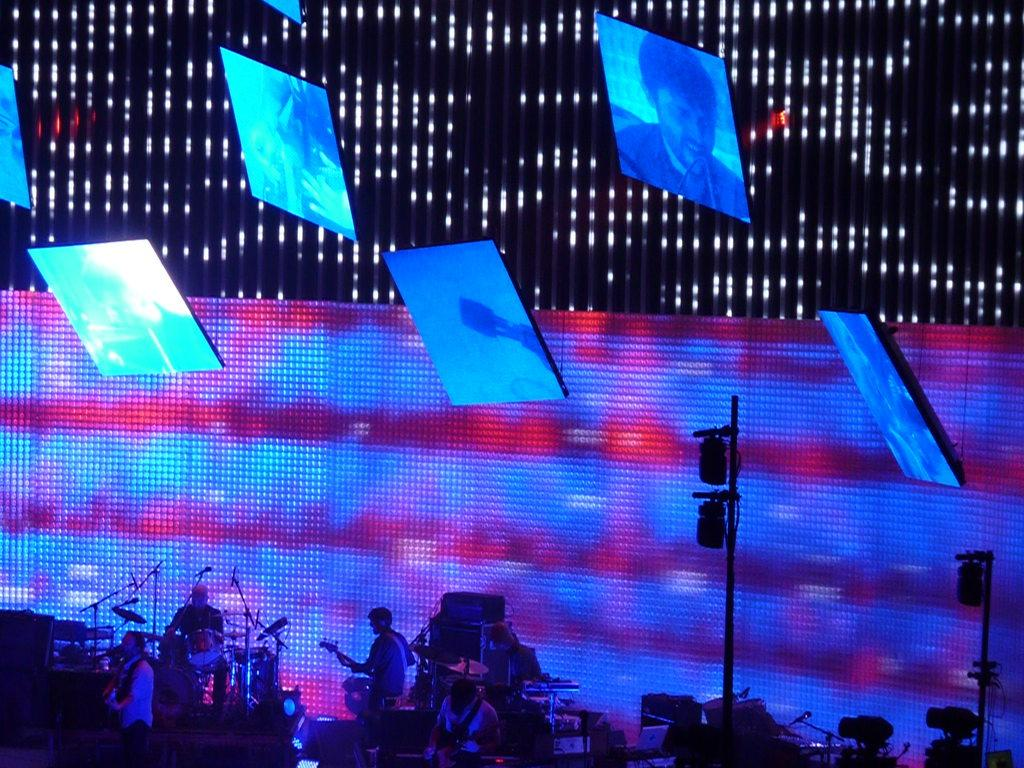What objects are located at the bottom of the image? There are musical instruments, persons, lights, and poles at the bottom of the image. What type of environment is depicted in the background of the image? The background of the image features boards with lights and screens. Can you describe the lighting setup in the image? There are lights at the bottom of the image and boards with lights in the background. What type of bird can be seen perched on the musical instruments in the image? There are no birds visible in the image, including robins. Can you describe the tiger's behavior in the image? There is no tiger present in the image. 